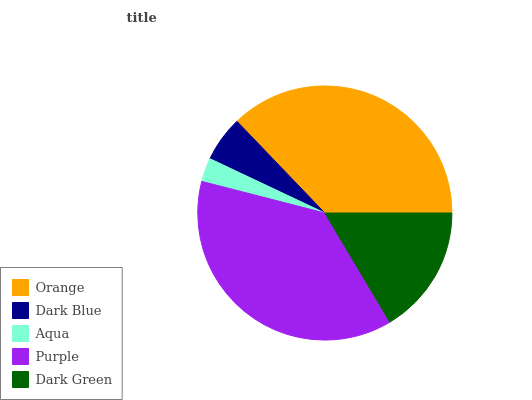Is Aqua the minimum?
Answer yes or no. Yes. Is Purple the maximum?
Answer yes or no. Yes. Is Dark Blue the minimum?
Answer yes or no. No. Is Dark Blue the maximum?
Answer yes or no. No. Is Orange greater than Dark Blue?
Answer yes or no. Yes. Is Dark Blue less than Orange?
Answer yes or no. Yes. Is Dark Blue greater than Orange?
Answer yes or no. No. Is Orange less than Dark Blue?
Answer yes or no. No. Is Dark Green the high median?
Answer yes or no. Yes. Is Dark Green the low median?
Answer yes or no. Yes. Is Orange the high median?
Answer yes or no. No. Is Dark Blue the low median?
Answer yes or no. No. 